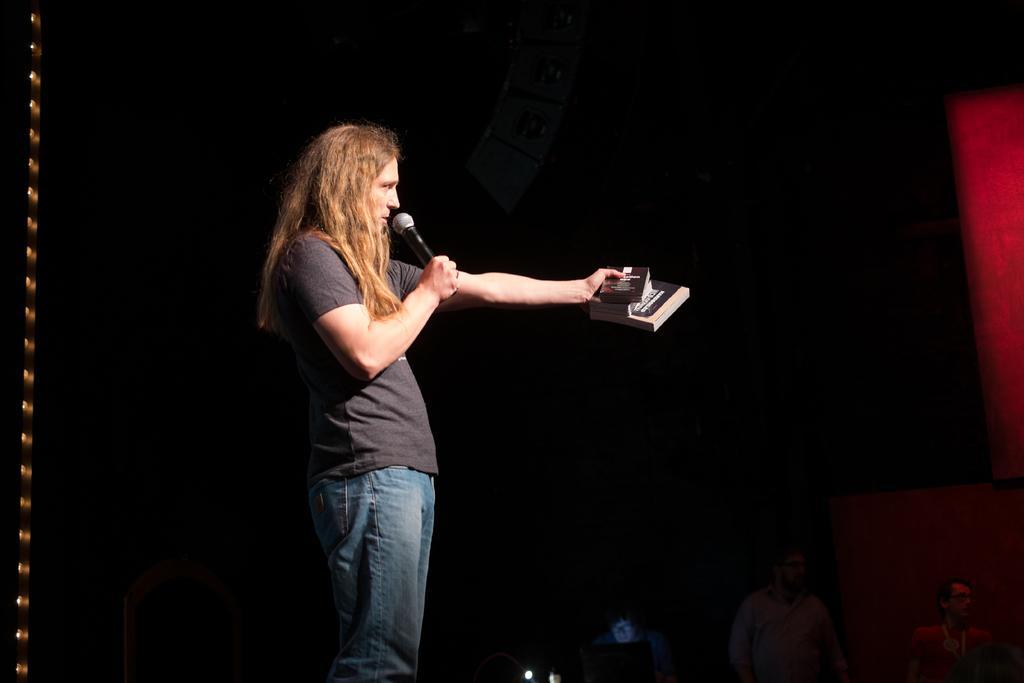In one or two sentences, can you explain what this image depicts? In this image In the middle there is a man he wear t shirt and trouser he is holding mic and books. In the background there are some people and light. 